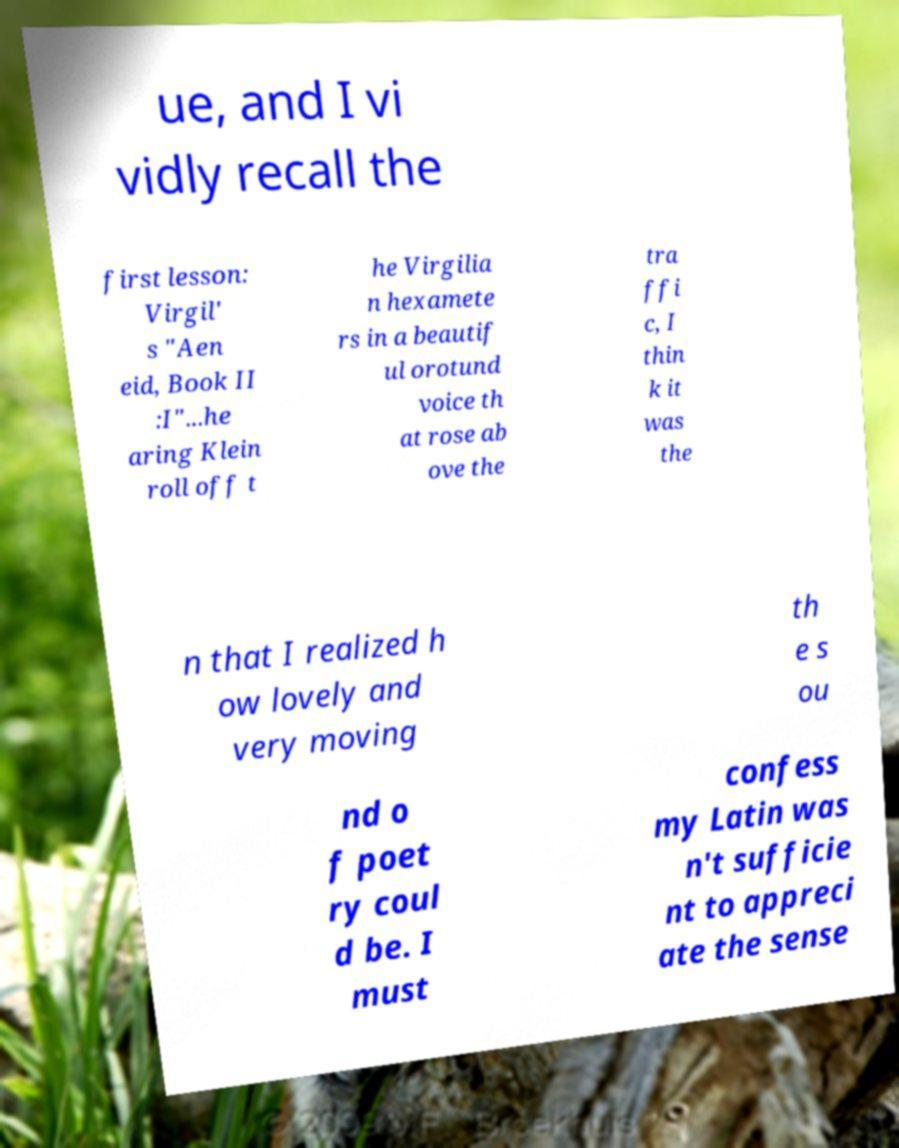For documentation purposes, I need the text within this image transcribed. Could you provide that? ue, and I vi vidly recall the first lesson: Virgil' s "Aen eid, Book II :I"...he aring Klein roll off t he Virgilia n hexamete rs in a beautif ul orotund voice th at rose ab ove the tra ffi c, I thin k it was the n that I realized h ow lovely and very moving th e s ou nd o f poet ry coul d be. I must confess my Latin was n't sufficie nt to appreci ate the sense 